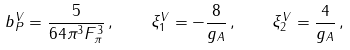Convert formula to latex. <formula><loc_0><loc_0><loc_500><loc_500>b _ { P } ^ { V } = \frac { 5 } { 6 4 \pi ^ { 3 } F ^ { 3 } _ { \pi } } \, , \quad \xi _ { 1 } ^ { V } = - \frac { 8 } { g _ { A } } \, , \quad \xi _ { 2 } ^ { V } = \frac { 4 } { g _ { A } } \, ,</formula> 